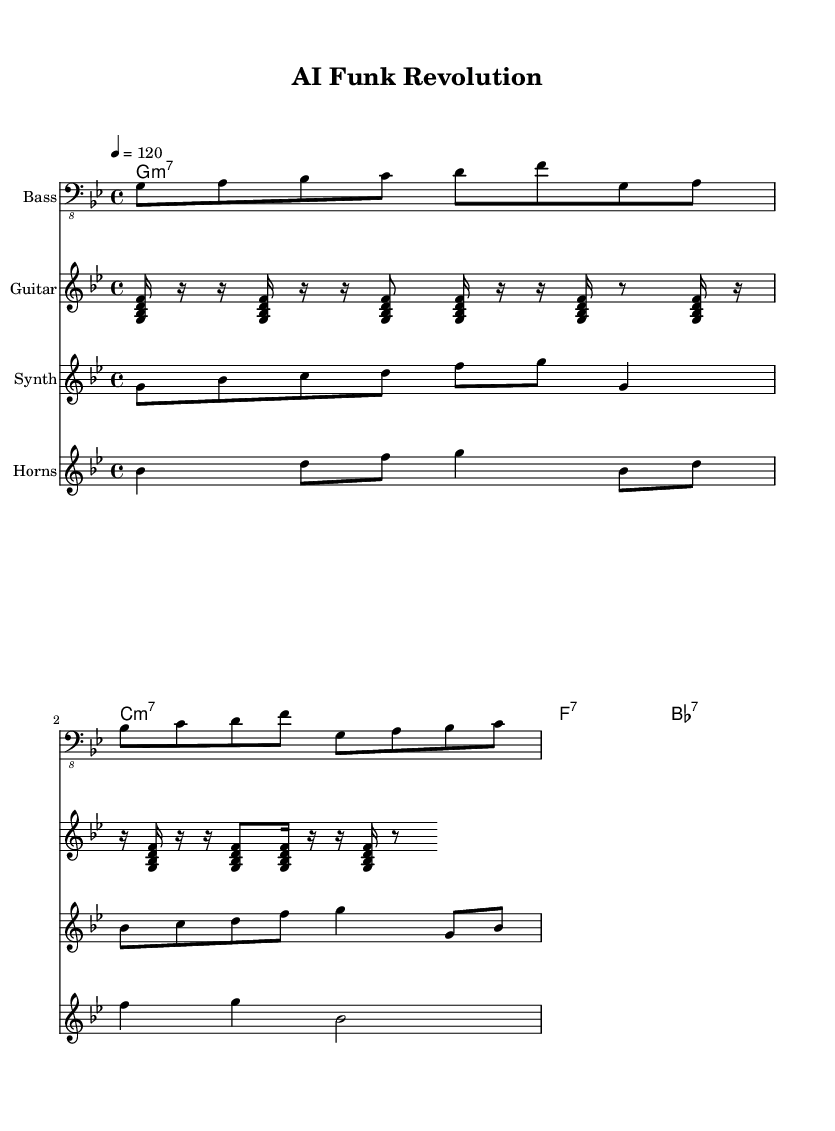What is the key signature of this music? The key signature is G minor, which has two flats (B♭ and E♭). This can be identified at the beginning of the sheet music where the key signature is shown.
Answer: G minor What is the time signature of the piece? The time signature is 4/4, indicated at the start of the score. This means there are four beats per measure, and the quarter note gets one beat.
Answer: 4/4 What is the tempo marking for the music? The tempo marking is 120 beats per minute, specified at the start of the score. This indicates that the piece should be played at a moderate speed.
Answer: 120 How many instruments are featured in the score? There are four instruments featured: Bass, Guitar, Synth, and Horns. This is identifiable from the individual staff headings provided for each instrument.
Answer: Four What is the chord progression used in the piece? The chord progression consists of G minor 7, C minor 7, F 7, and B flat 7. This progression is specified under the ChordNames section.
Answer: G minor 7, C minor 7, F 7, B flat 7 How is the guitar part structured in terms of rhythmic variation? The guitar part uses repeated rhythmic patterns with alternating rests and notes, as indicated throughout its lines. The use of 16th notes and some rests creates a syncopated feel typical of funk music.
Answer: Syncopated rhythm What is the purpose of the horn section in funk music? The horn section typically adds melodic and harmonic layers and enhances the groove with punctuated accents, which is evident from its rhythmic and harmonic structure in the score.
Answer: Enhance groove 